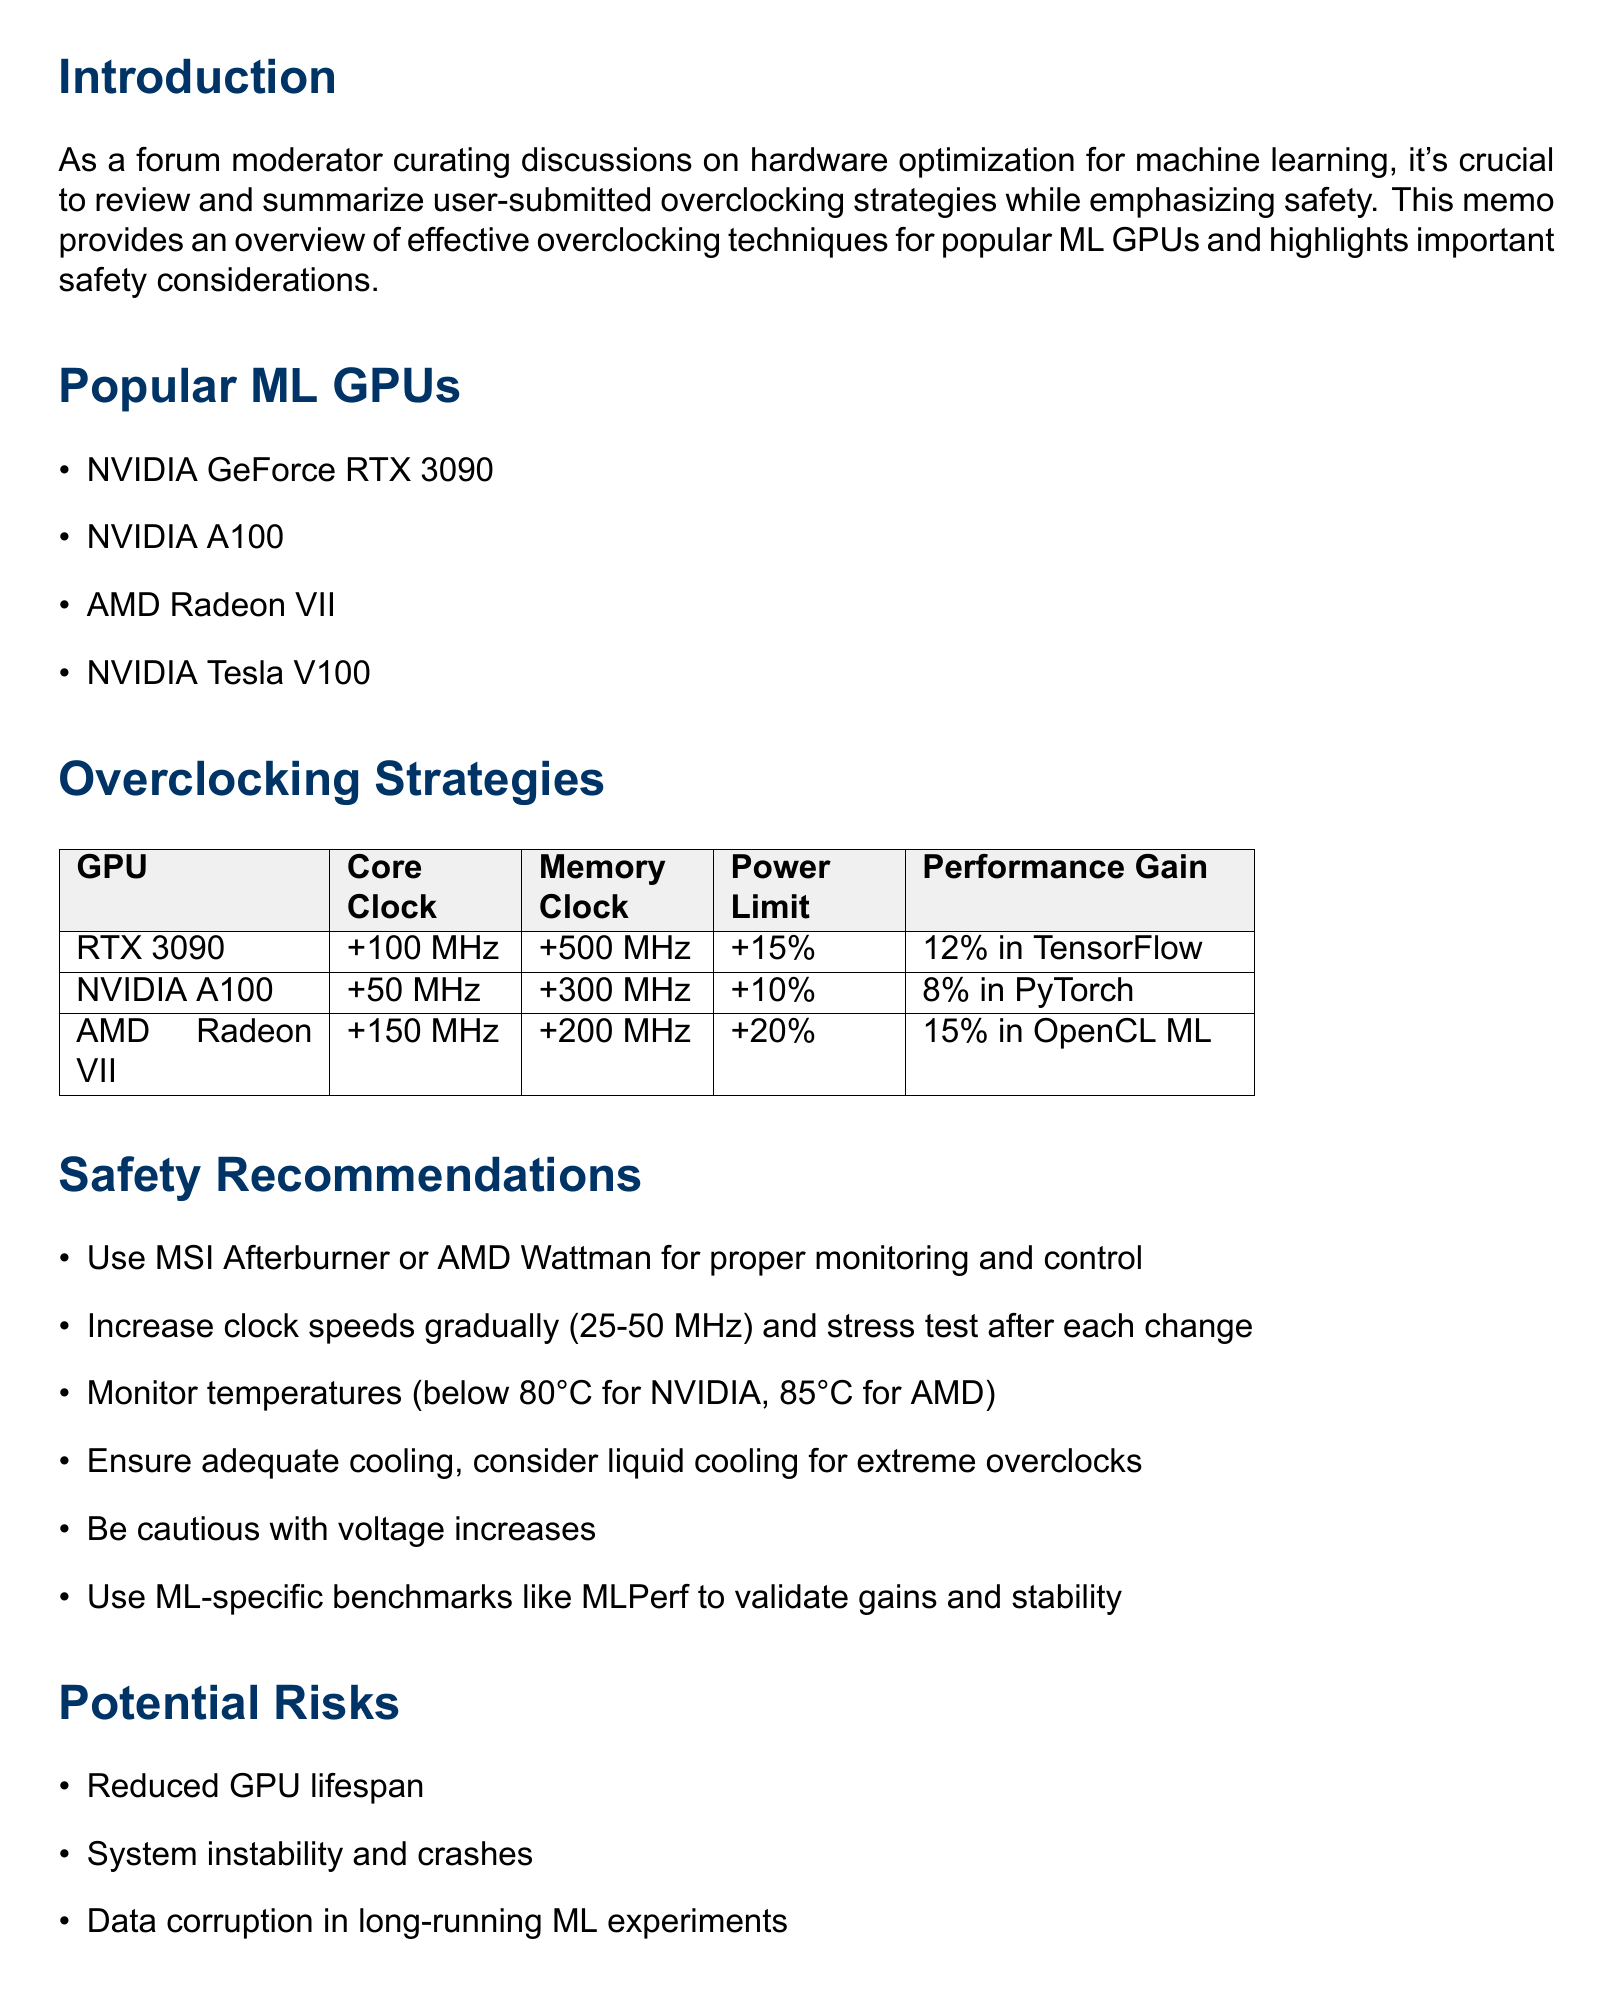What is the title of the memo? The title provides the main subject of the document, which summarizes the content of the memo about overclocking strategies for GPUs.
Answer: Review of User-Submitted Overclocking Strategies for Popular Machine Learning GPUs, with Safety Recommendations How much is the power limit increase for NVIDIA GeForce RTX 3090? This information is detailed in the overclocking strategies section, specifically for the RTX 3090.
Answer: 15% What is the user-reported performance gain for AMD Radeon VII? The document specifies the performance gain reported by users for the AMD Radeon VII in ML frameworks.
Answer: 15% in OpenCL-based ML frameworks What is the maximum temperature advised for NVIDIA GPUs? The safety recommendations provide a critical temperature limit for NVIDIA GPUs to ensure safe operation during overclocking.
Answer: 80°C Which tool is recommended for monitoring and control when overclocking? The document mentions specific software tools to use during the overclocking process for effective monitoring and control of GPU parameters.
Answer: MSI Afterburner or AMD Wattman What is a potential risk of overclocking? The document outlines several risks associated with overclocking high-end machine learning GPUs, highlighting potential negative impacts.
Answer: Reduced GPU lifespan What should be done before making changes to the GPU? The best practices in the document call for a specific preparatory step before any modifications are made to the GPU settings.
Answer: Create a backup of GPU BIOS What is emphasized in the conclusion regarding overclocking? The conclusion summarizes the importance of a specific aspect that should not be overlooked during overclocking pursuits, focusing on overall system health.
Answer: Prioritize system stability and GPU longevity 